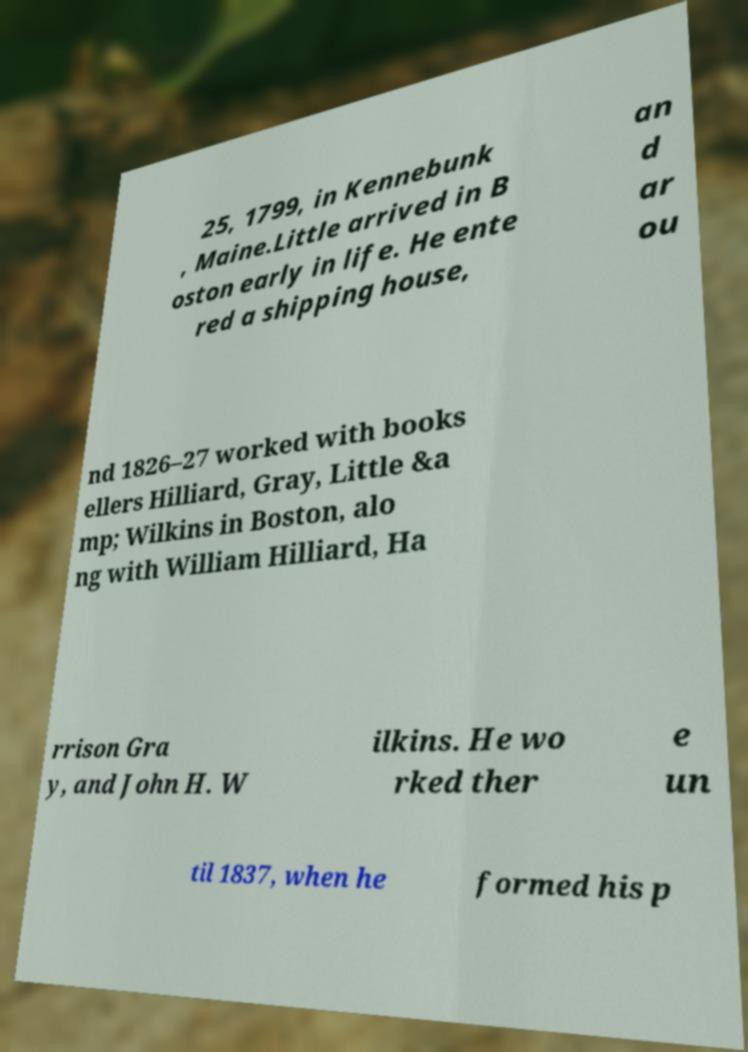Could you extract and type out the text from this image? 25, 1799, in Kennebunk , Maine.Little arrived in B oston early in life. He ente red a shipping house, an d ar ou nd 1826–27 worked with books ellers Hilliard, Gray, Little &a mp; Wilkins in Boston, alo ng with William Hilliard, Ha rrison Gra y, and John H. W ilkins. He wo rked ther e un til 1837, when he formed his p 